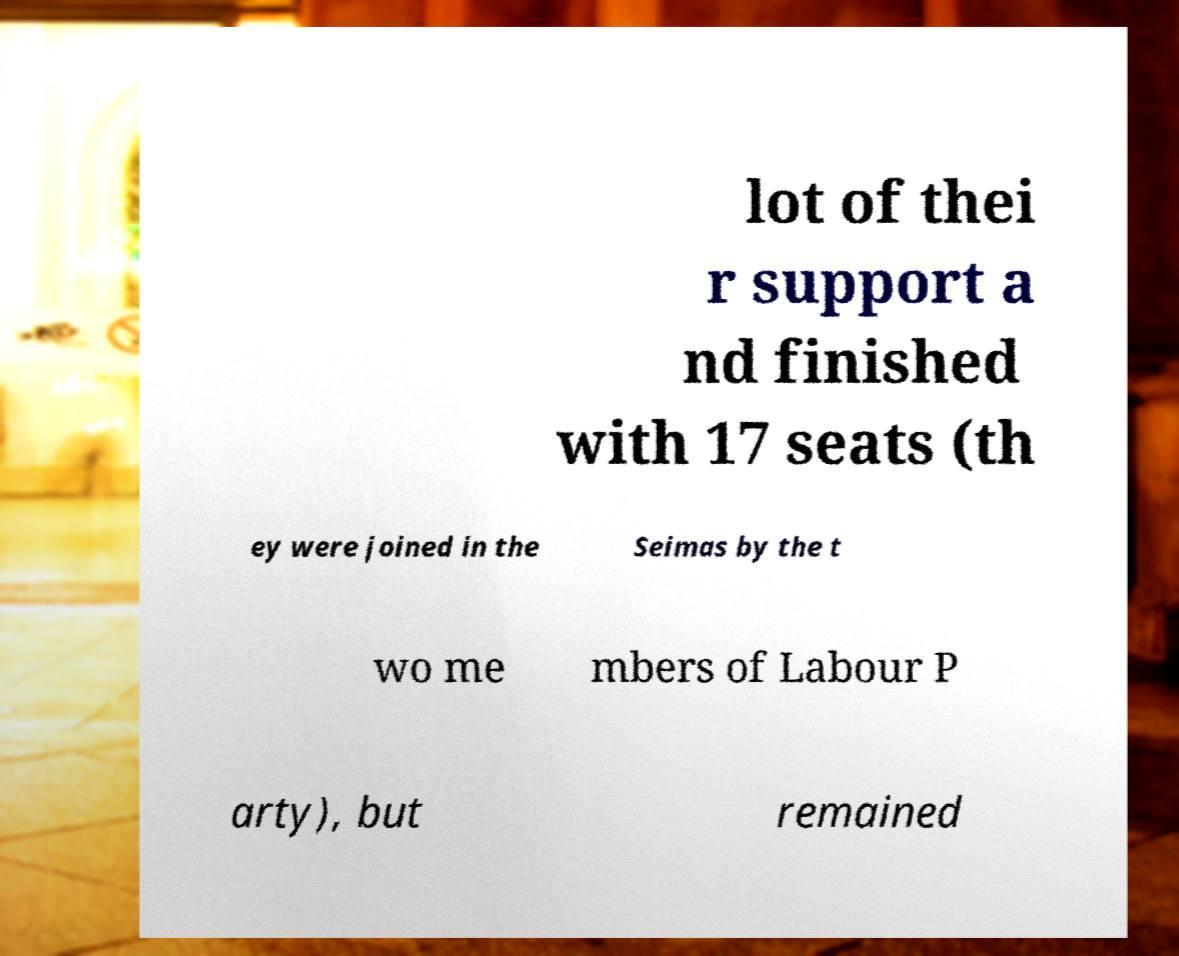For documentation purposes, I need the text within this image transcribed. Could you provide that? lot of thei r support a nd finished with 17 seats (th ey were joined in the Seimas by the t wo me mbers of Labour P arty), but remained 